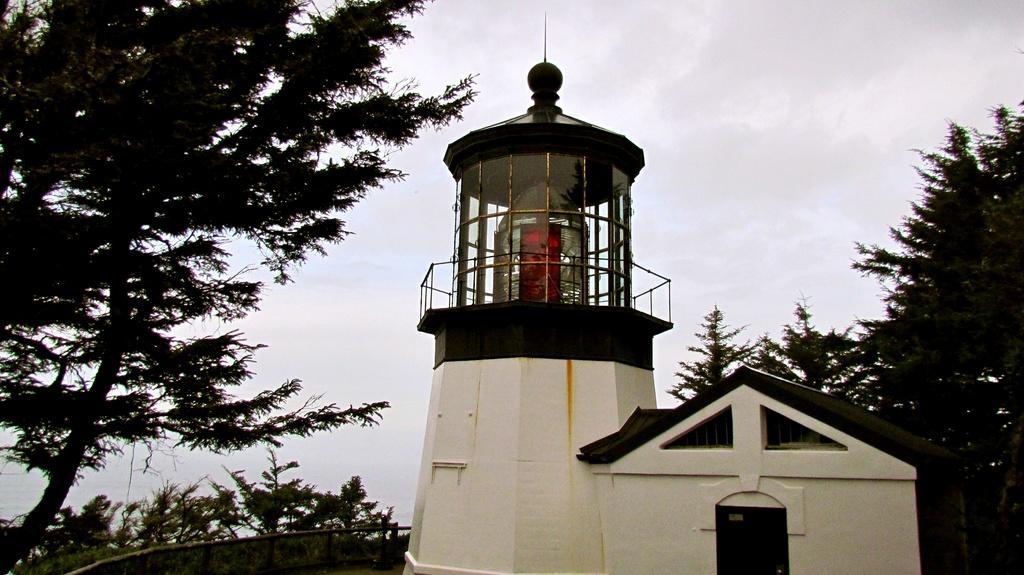Could you give a brief overview of what you see in this image? In this image we can see a house and also a small tower. We can also see the fence, trees and also the sky. 